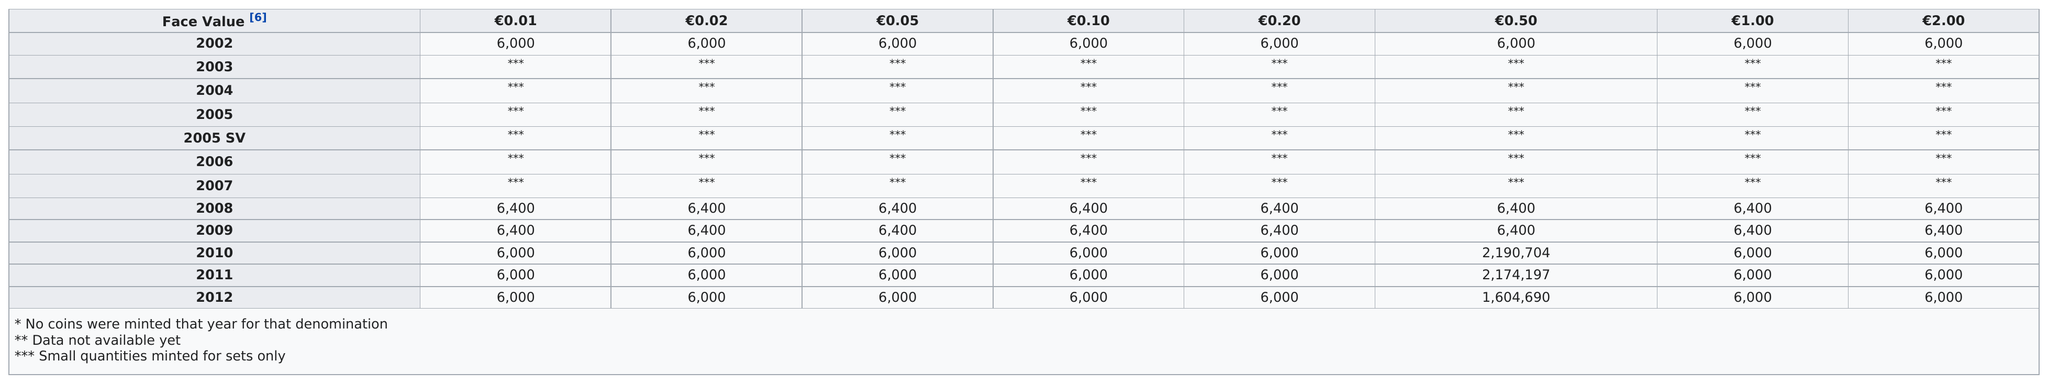Mention a couple of crucial points in this snapshot. The total number of values in column 1 for all face values is 36,800. The most amount of money in 2012 was 1,604,690. In 2010, approximately 6,000 banknotes with a face value of 0.01 were in circulation. In 2011, the total face value of 1.00 was 6,000. The year after 2005 is 2006. 